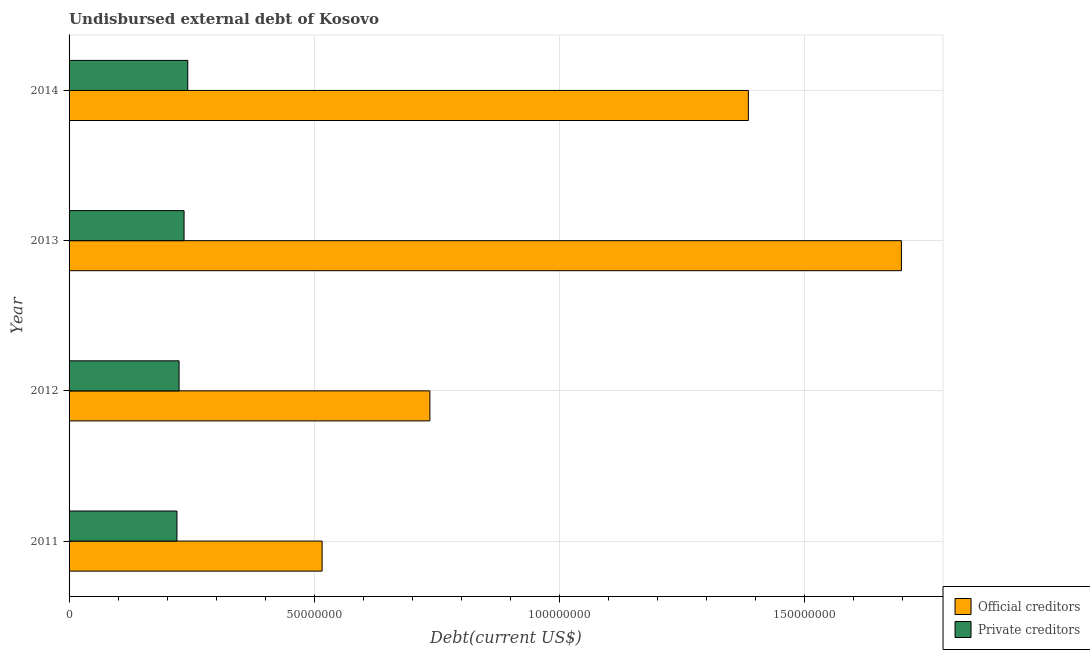How many different coloured bars are there?
Give a very brief answer. 2. How many groups of bars are there?
Your response must be concise. 4. Are the number of bars per tick equal to the number of legend labels?
Ensure brevity in your answer.  Yes. How many bars are there on the 2nd tick from the top?
Provide a short and direct response. 2. How many bars are there on the 3rd tick from the bottom?
Provide a short and direct response. 2. What is the label of the 3rd group of bars from the top?
Make the answer very short. 2012. In how many cases, is the number of bars for a given year not equal to the number of legend labels?
Your answer should be very brief. 0. What is the undisbursed external debt of official creditors in 2012?
Your answer should be very brief. 7.36e+07. Across all years, what is the maximum undisbursed external debt of private creditors?
Provide a short and direct response. 2.42e+07. Across all years, what is the minimum undisbursed external debt of private creditors?
Make the answer very short. 2.20e+07. What is the total undisbursed external debt of private creditors in the graph?
Ensure brevity in your answer.  9.21e+07. What is the difference between the undisbursed external debt of official creditors in 2011 and that in 2013?
Offer a terse response. -1.18e+08. What is the difference between the undisbursed external debt of private creditors in 2012 and the undisbursed external debt of official creditors in 2014?
Give a very brief answer. -1.16e+08. What is the average undisbursed external debt of private creditors per year?
Offer a terse response. 2.30e+07. In the year 2013, what is the difference between the undisbursed external debt of private creditors and undisbursed external debt of official creditors?
Make the answer very short. -1.46e+08. In how many years, is the undisbursed external debt of official creditors greater than 160000000 US$?
Make the answer very short. 1. What is the ratio of the undisbursed external debt of official creditors in 2011 to that in 2012?
Provide a succinct answer. 0.7. Is the undisbursed external debt of official creditors in 2012 less than that in 2013?
Provide a short and direct response. Yes. Is the difference between the undisbursed external debt of official creditors in 2011 and 2013 greater than the difference between the undisbursed external debt of private creditors in 2011 and 2013?
Offer a terse response. No. What is the difference between the highest and the second highest undisbursed external debt of private creditors?
Your response must be concise. 7.54e+05. What is the difference between the highest and the lowest undisbursed external debt of official creditors?
Offer a very short reply. 1.18e+08. What does the 2nd bar from the top in 2013 represents?
Provide a short and direct response. Official creditors. What does the 1st bar from the bottom in 2014 represents?
Your answer should be compact. Official creditors. What is the difference between two consecutive major ticks on the X-axis?
Give a very brief answer. 5.00e+07. Where does the legend appear in the graph?
Give a very brief answer. Bottom right. How many legend labels are there?
Make the answer very short. 2. What is the title of the graph?
Make the answer very short. Undisbursed external debt of Kosovo. What is the label or title of the X-axis?
Provide a short and direct response. Debt(current US$). What is the label or title of the Y-axis?
Your answer should be very brief. Year. What is the Debt(current US$) in Official creditors in 2011?
Your response must be concise. 5.16e+07. What is the Debt(current US$) of Private creditors in 2011?
Offer a terse response. 2.20e+07. What is the Debt(current US$) of Official creditors in 2012?
Provide a short and direct response. 7.36e+07. What is the Debt(current US$) in Private creditors in 2012?
Offer a very short reply. 2.24e+07. What is the Debt(current US$) in Official creditors in 2013?
Offer a terse response. 1.70e+08. What is the Debt(current US$) of Private creditors in 2013?
Provide a short and direct response. 2.34e+07. What is the Debt(current US$) in Official creditors in 2014?
Provide a succinct answer. 1.38e+08. What is the Debt(current US$) of Private creditors in 2014?
Your answer should be very brief. 2.42e+07. Across all years, what is the maximum Debt(current US$) of Official creditors?
Provide a succinct answer. 1.70e+08. Across all years, what is the maximum Debt(current US$) in Private creditors?
Your answer should be compact. 2.42e+07. Across all years, what is the minimum Debt(current US$) of Official creditors?
Offer a terse response. 5.16e+07. Across all years, what is the minimum Debt(current US$) in Private creditors?
Your answer should be compact. 2.20e+07. What is the total Debt(current US$) of Official creditors in the graph?
Keep it short and to the point. 4.33e+08. What is the total Debt(current US$) in Private creditors in the graph?
Provide a short and direct response. 9.21e+07. What is the difference between the Debt(current US$) in Official creditors in 2011 and that in 2012?
Offer a terse response. -2.20e+07. What is the difference between the Debt(current US$) of Private creditors in 2011 and that in 2012?
Ensure brevity in your answer.  -4.34e+05. What is the difference between the Debt(current US$) of Official creditors in 2011 and that in 2013?
Your response must be concise. -1.18e+08. What is the difference between the Debt(current US$) of Private creditors in 2011 and that in 2013?
Provide a short and direct response. -1.45e+06. What is the difference between the Debt(current US$) in Official creditors in 2011 and that in 2014?
Your answer should be compact. -8.69e+07. What is the difference between the Debt(current US$) in Private creditors in 2011 and that in 2014?
Your response must be concise. -2.20e+06. What is the difference between the Debt(current US$) in Official creditors in 2012 and that in 2013?
Your answer should be very brief. -9.61e+07. What is the difference between the Debt(current US$) of Private creditors in 2012 and that in 2013?
Provide a short and direct response. -1.02e+06. What is the difference between the Debt(current US$) in Official creditors in 2012 and that in 2014?
Offer a very short reply. -6.49e+07. What is the difference between the Debt(current US$) of Private creditors in 2012 and that in 2014?
Provide a succinct answer. -1.77e+06. What is the difference between the Debt(current US$) of Official creditors in 2013 and that in 2014?
Keep it short and to the point. 3.12e+07. What is the difference between the Debt(current US$) of Private creditors in 2013 and that in 2014?
Provide a short and direct response. -7.54e+05. What is the difference between the Debt(current US$) of Official creditors in 2011 and the Debt(current US$) of Private creditors in 2012?
Your answer should be compact. 2.92e+07. What is the difference between the Debt(current US$) in Official creditors in 2011 and the Debt(current US$) in Private creditors in 2013?
Offer a very short reply. 2.81e+07. What is the difference between the Debt(current US$) in Official creditors in 2011 and the Debt(current US$) in Private creditors in 2014?
Provide a succinct answer. 2.74e+07. What is the difference between the Debt(current US$) in Official creditors in 2012 and the Debt(current US$) in Private creditors in 2013?
Give a very brief answer. 5.01e+07. What is the difference between the Debt(current US$) of Official creditors in 2012 and the Debt(current US$) of Private creditors in 2014?
Your response must be concise. 4.94e+07. What is the difference between the Debt(current US$) of Official creditors in 2013 and the Debt(current US$) of Private creditors in 2014?
Your answer should be compact. 1.46e+08. What is the average Debt(current US$) in Official creditors per year?
Your answer should be compact. 1.08e+08. What is the average Debt(current US$) in Private creditors per year?
Give a very brief answer. 2.30e+07. In the year 2011, what is the difference between the Debt(current US$) of Official creditors and Debt(current US$) of Private creditors?
Your answer should be compact. 2.96e+07. In the year 2012, what is the difference between the Debt(current US$) in Official creditors and Debt(current US$) in Private creditors?
Make the answer very short. 5.11e+07. In the year 2013, what is the difference between the Debt(current US$) in Official creditors and Debt(current US$) in Private creditors?
Offer a terse response. 1.46e+08. In the year 2014, what is the difference between the Debt(current US$) in Official creditors and Debt(current US$) in Private creditors?
Keep it short and to the point. 1.14e+08. What is the ratio of the Debt(current US$) in Official creditors in 2011 to that in 2012?
Your answer should be very brief. 0.7. What is the ratio of the Debt(current US$) in Private creditors in 2011 to that in 2012?
Offer a very short reply. 0.98. What is the ratio of the Debt(current US$) in Official creditors in 2011 to that in 2013?
Keep it short and to the point. 0.3. What is the ratio of the Debt(current US$) of Private creditors in 2011 to that in 2013?
Your answer should be compact. 0.94. What is the ratio of the Debt(current US$) in Official creditors in 2011 to that in 2014?
Provide a short and direct response. 0.37. What is the ratio of the Debt(current US$) in Private creditors in 2011 to that in 2014?
Your answer should be very brief. 0.91. What is the ratio of the Debt(current US$) of Official creditors in 2012 to that in 2013?
Your answer should be compact. 0.43. What is the ratio of the Debt(current US$) of Private creditors in 2012 to that in 2013?
Provide a short and direct response. 0.96. What is the ratio of the Debt(current US$) in Official creditors in 2012 to that in 2014?
Give a very brief answer. 0.53. What is the ratio of the Debt(current US$) of Private creditors in 2012 to that in 2014?
Make the answer very short. 0.93. What is the ratio of the Debt(current US$) of Official creditors in 2013 to that in 2014?
Your answer should be compact. 1.23. What is the ratio of the Debt(current US$) in Private creditors in 2013 to that in 2014?
Ensure brevity in your answer.  0.97. What is the difference between the highest and the second highest Debt(current US$) of Official creditors?
Offer a terse response. 3.12e+07. What is the difference between the highest and the second highest Debt(current US$) of Private creditors?
Offer a very short reply. 7.54e+05. What is the difference between the highest and the lowest Debt(current US$) in Official creditors?
Your answer should be compact. 1.18e+08. What is the difference between the highest and the lowest Debt(current US$) in Private creditors?
Provide a short and direct response. 2.20e+06. 